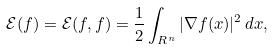Convert formula to latex. <formula><loc_0><loc_0><loc_500><loc_500>\mathcal { E } ( f ) = \mathcal { E } ( f , f ) = \frac { 1 } { 2 } \int _ { { R } ^ { n } } | \nabla f ( x ) | ^ { 2 } \, d x ,</formula> 